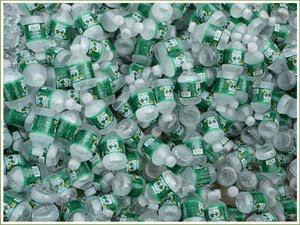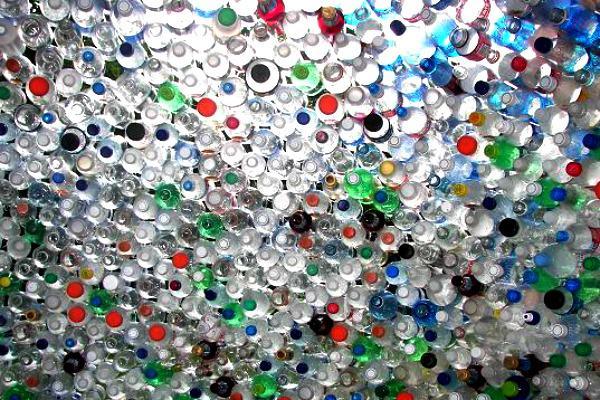The first image is the image on the left, the second image is the image on the right. Assess this claim about the two images: "At least one image shows a large mass of water bottles.". Correct or not? Answer yes or no. Yes. 